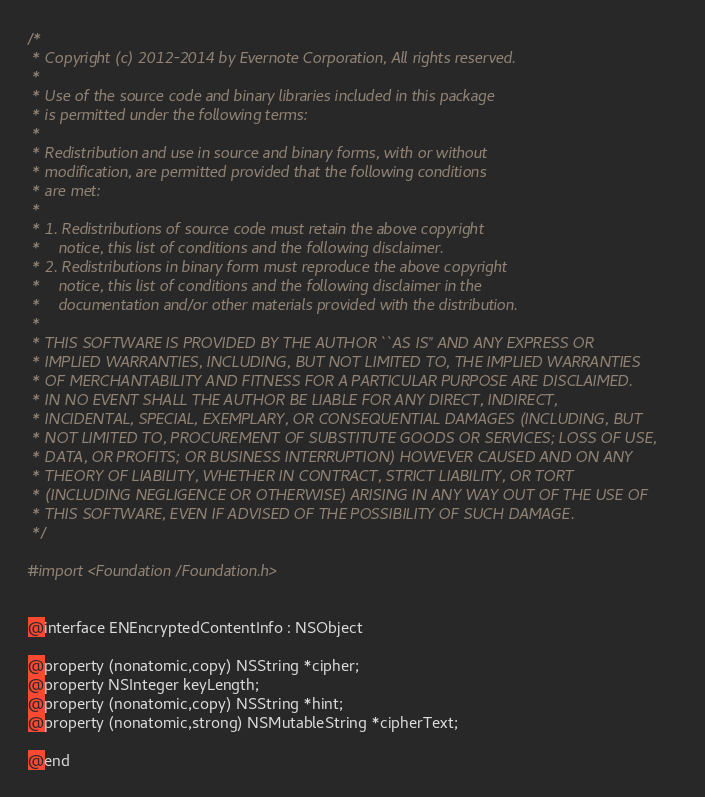Convert code to text. <code><loc_0><loc_0><loc_500><loc_500><_C_>/*
 * Copyright (c) 2012-2014 by Evernote Corporation, All rights reserved.
 *
 * Use of the source code and binary libraries included in this package
 * is permitted under the following terms:
 *
 * Redistribution and use in source and binary forms, with or without
 * modification, are permitted provided that the following conditions
 * are met:
 *
 * 1. Redistributions of source code must retain the above copyright
 *    notice, this list of conditions and the following disclaimer.
 * 2. Redistributions in binary form must reproduce the above copyright
 *    notice, this list of conditions and the following disclaimer in the
 *    documentation and/or other materials provided with the distribution.
 *
 * THIS SOFTWARE IS PROVIDED BY THE AUTHOR ``AS IS'' AND ANY EXPRESS OR
 * IMPLIED WARRANTIES, INCLUDING, BUT NOT LIMITED TO, THE IMPLIED WARRANTIES
 * OF MERCHANTABILITY AND FITNESS FOR A PARTICULAR PURPOSE ARE DISCLAIMED.
 * IN NO EVENT SHALL THE AUTHOR BE LIABLE FOR ANY DIRECT, INDIRECT,
 * INCIDENTAL, SPECIAL, EXEMPLARY, OR CONSEQUENTIAL DAMAGES (INCLUDING, BUT
 * NOT LIMITED TO, PROCUREMENT OF SUBSTITUTE GOODS OR SERVICES; LOSS OF USE,
 * DATA, OR PROFITS; OR BUSINESS INTERRUPTION) HOWEVER CAUSED AND ON ANY
 * THEORY OF LIABILITY, WHETHER IN CONTRACT, STRICT LIABILITY, OR TORT
 * (INCLUDING NEGLIGENCE OR OTHERWISE) ARISING IN ANY WAY OUT OF THE USE OF
 * THIS SOFTWARE, EVEN IF ADVISED OF THE POSSIBILITY OF SUCH DAMAGE.
 */

#import <Foundation/Foundation.h>


@interface ENEncryptedContentInfo : NSObject

@property (nonatomic,copy) NSString *cipher;
@property NSInteger keyLength;
@property (nonatomic,copy) NSString *hint;
@property (nonatomic,strong) NSMutableString *cipherText;

@end
</code> 